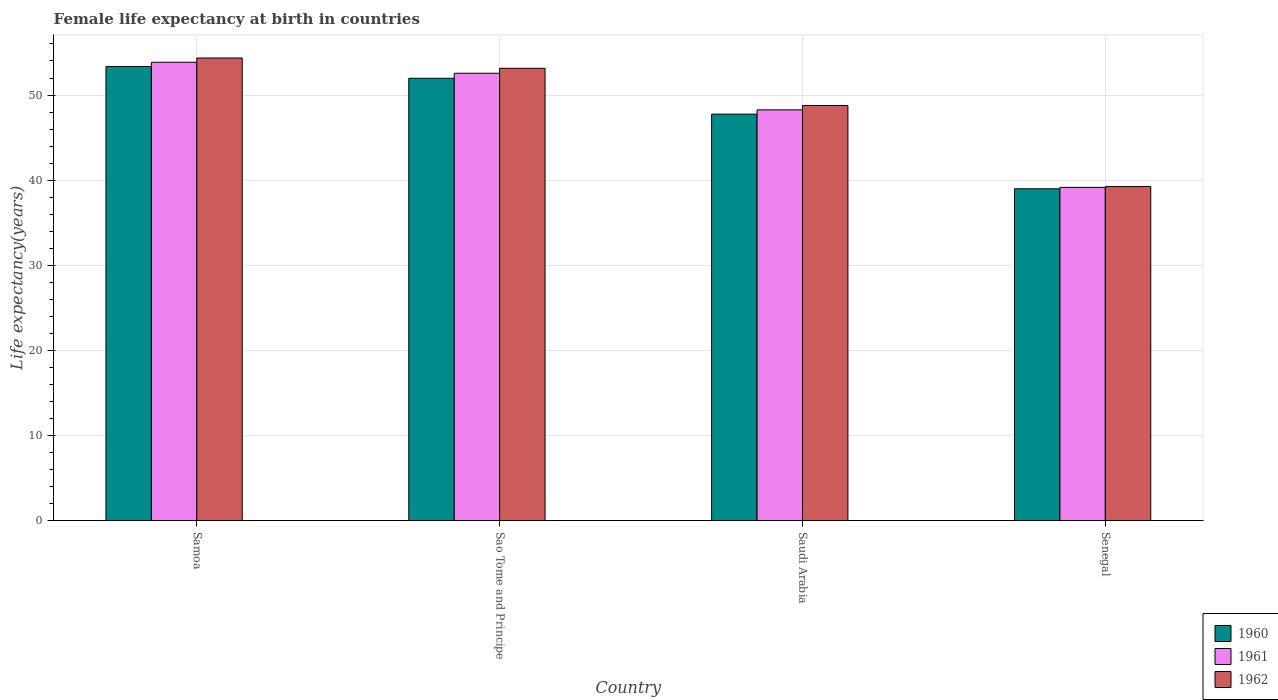How many different coloured bars are there?
Offer a very short reply. 3. How many bars are there on the 4th tick from the left?
Your answer should be compact. 3. What is the label of the 3rd group of bars from the left?
Your answer should be compact. Saudi Arabia. What is the female life expectancy at birth in 1962 in Saudi Arabia?
Your answer should be compact. 48.77. Across all countries, what is the maximum female life expectancy at birth in 1961?
Keep it short and to the point. 53.85. Across all countries, what is the minimum female life expectancy at birth in 1960?
Make the answer very short. 38.98. In which country was the female life expectancy at birth in 1961 maximum?
Offer a very short reply. Samoa. In which country was the female life expectancy at birth in 1961 minimum?
Your answer should be compact. Senegal. What is the total female life expectancy at birth in 1961 in the graph?
Your response must be concise. 193.82. What is the difference between the female life expectancy at birth in 1961 in Samoa and that in Senegal?
Your answer should be compact. 14.7. What is the difference between the female life expectancy at birth in 1960 in Sao Tome and Principe and the female life expectancy at birth in 1961 in Saudi Arabia?
Ensure brevity in your answer.  3.71. What is the average female life expectancy at birth in 1962 per country?
Offer a terse response. 48.88. What is the difference between the female life expectancy at birth of/in 1960 and female life expectancy at birth of/in 1961 in Saudi Arabia?
Ensure brevity in your answer.  -0.5. In how many countries, is the female life expectancy at birth in 1960 greater than 26 years?
Give a very brief answer. 4. What is the ratio of the female life expectancy at birth in 1961 in Samoa to that in Sao Tome and Principe?
Your answer should be very brief. 1.02. Is the female life expectancy at birth in 1961 in Sao Tome and Principe less than that in Saudi Arabia?
Your answer should be compact. No. What is the difference between the highest and the second highest female life expectancy at birth in 1961?
Provide a succinct answer. -4.3. What is the difference between the highest and the lowest female life expectancy at birth in 1960?
Your answer should be very brief. 14.37. In how many countries, is the female life expectancy at birth in 1961 greater than the average female life expectancy at birth in 1961 taken over all countries?
Give a very brief answer. 2. Is the sum of the female life expectancy at birth in 1962 in Sao Tome and Principe and Saudi Arabia greater than the maximum female life expectancy at birth in 1960 across all countries?
Your response must be concise. Yes. What does the 3rd bar from the left in Senegal represents?
Your response must be concise. 1962. How many bars are there?
Your answer should be very brief. 12. Are all the bars in the graph horizontal?
Provide a short and direct response. No. How many countries are there in the graph?
Your response must be concise. 4. What is the difference between two consecutive major ticks on the Y-axis?
Your answer should be compact. 10. Are the values on the major ticks of Y-axis written in scientific E-notation?
Your answer should be very brief. No. How are the legend labels stacked?
Your answer should be very brief. Vertical. What is the title of the graph?
Give a very brief answer. Female life expectancy at birth in countries. Does "2013" appear as one of the legend labels in the graph?
Your answer should be compact. No. What is the label or title of the Y-axis?
Provide a short and direct response. Life expectancy(years). What is the Life expectancy(years) of 1960 in Samoa?
Offer a terse response. 53.35. What is the Life expectancy(years) in 1961 in Samoa?
Your response must be concise. 53.85. What is the Life expectancy(years) in 1962 in Samoa?
Provide a short and direct response. 54.35. What is the Life expectancy(years) in 1960 in Sao Tome and Principe?
Give a very brief answer. 51.97. What is the Life expectancy(years) of 1961 in Sao Tome and Principe?
Make the answer very short. 52.56. What is the Life expectancy(years) in 1962 in Sao Tome and Principe?
Your answer should be compact. 53.14. What is the Life expectancy(years) of 1960 in Saudi Arabia?
Your response must be concise. 47.76. What is the Life expectancy(years) in 1961 in Saudi Arabia?
Your response must be concise. 48.26. What is the Life expectancy(years) in 1962 in Saudi Arabia?
Provide a succinct answer. 48.77. What is the Life expectancy(years) in 1960 in Senegal?
Your response must be concise. 38.98. What is the Life expectancy(years) in 1961 in Senegal?
Make the answer very short. 39.15. What is the Life expectancy(years) of 1962 in Senegal?
Offer a very short reply. 39.24. Across all countries, what is the maximum Life expectancy(years) of 1960?
Ensure brevity in your answer.  53.35. Across all countries, what is the maximum Life expectancy(years) in 1961?
Make the answer very short. 53.85. Across all countries, what is the maximum Life expectancy(years) in 1962?
Provide a short and direct response. 54.35. Across all countries, what is the minimum Life expectancy(years) in 1960?
Provide a succinct answer. 38.98. Across all countries, what is the minimum Life expectancy(years) of 1961?
Your answer should be compact. 39.15. Across all countries, what is the minimum Life expectancy(years) in 1962?
Provide a short and direct response. 39.24. What is the total Life expectancy(years) of 1960 in the graph?
Your response must be concise. 192.06. What is the total Life expectancy(years) of 1961 in the graph?
Your answer should be compact. 193.82. What is the total Life expectancy(years) in 1962 in the graph?
Provide a succinct answer. 195.51. What is the difference between the Life expectancy(years) of 1960 in Samoa and that in Sao Tome and Principe?
Your answer should be compact. 1.38. What is the difference between the Life expectancy(years) in 1961 in Samoa and that in Sao Tome and Principe?
Offer a very short reply. 1.29. What is the difference between the Life expectancy(years) of 1962 in Samoa and that in Sao Tome and Principe?
Make the answer very short. 1.21. What is the difference between the Life expectancy(years) in 1960 in Samoa and that in Saudi Arabia?
Your response must be concise. 5.59. What is the difference between the Life expectancy(years) in 1961 in Samoa and that in Saudi Arabia?
Your answer should be very brief. 5.59. What is the difference between the Life expectancy(years) in 1962 in Samoa and that in Saudi Arabia?
Your answer should be compact. 5.58. What is the difference between the Life expectancy(years) of 1960 in Samoa and that in Senegal?
Provide a short and direct response. 14.37. What is the difference between the Life expectancy(years) of 1961 in Samoa and that in Senegal?
Provide a short and direct response. 14.7. What is the difference between the Life expectancy(years) in 1962 in Samoa and that in Senegal?
Give a very brief answer. 15.11. What is the difference between the Life expectancy(years) of 1960 in Sao Tome and Principe and that in Saudi Arabia?
Your answer should be compact. 4.21. What is the difference between the Life expectancy(years) of 1961 in Sao Tome and Principe and that in Saudi Arabia?
Your answer should be very brief. 4.3. What is the difference between the Life expectancy(years) of 1962 in Sao Tome and Principe and that in Saudi Arabia?
Your response must be concise. 4.37. What is the difference between the Life expectancy(years) of 1960 in Sao Tome and Principe and that in Senegal?
Keep it short and to the point. 12.99. What is the difference between the Life expectancy(years) of 1961 in Sao Tome and Principe and that in Senegal?
Provide a short and direct response. 13.41. What is the difference between the Life expectancy(years) of 1962 in Sao Tome and Principe and that in Senegal?
Your answer should be compact. 13.89. What is the difference between the Life expectancy(years) of 1960 in Saudi Arabia and that in Senegal?
Offer a terse response. 8.77. What is the difference between the Life expectancy(years) in 1961 in Saudi Arabia and that in Senegal?
Your response must be concise. 9.11. What is the difference between the Life expectancy(years) of 1962 in Saudi Arabia and that in Senegal?
Make the answer very short. 9.53. What is the difference between the Life expectancy(years) of 1960 in Samoa and the Life expectancy(years) of 1961 in Sao Tome and Principe?
Keep it short and to the point. 0.79. What is the difference between the Life expectancy(years) of 1960 in Samoa and the Life expectancy(years) of 1962 in Sao Tome and Principe?
Keep it short and to the point. 0.21. What is the difference between the Life expectancy(years) in 1961 in Samoa and the Life expectancy(years) in 1962 in Sao Tome and Principe?
Ensure brevity in your answer.  0.71. What is the difference between the Life expectancy(years) in 1960 in Samoa and the Life expectancy(years) in 1961 in Saudi Arabia?
Your response must be concise. 5.09. What is the difference between the Life expectancy(years) of 1960 in Samoa and the Life expectancy(years) of 1962 in Saudi Arabia?
Make the answer very short. 4.58. What is the difference between the Life expectancy(years) in 1961 in Samoa and the Life expectancy(years) in 1962 in Saudi Arabia?
Keep it short and to the point. 5.08. What is the difference between the Life expectancy(years) in 1960 in Samoa and the Life expectancy(years) in 1961 in Senegal?
Give a very brief answer. 14.2. What is the difference between the Life expectancy(years) of 1960 in Samoa and the Life expectancy(years) of 1962 in Senegal?
Your response must be concise. 14.11. What is the difference between the Life expectancy(years) in 1961 in Samoa and the Life expectancy(years) in 1962 in Senegal?
Your answer should be compact. 14.61. What is the difference between the Life expectancy(years) in 1960 in Sao Tome and Principe and the Life expectancy(years) in 1961 in Saudi Arabia?
Keep it short and to the point. 3.71. What is the difference between the Life expectancy(years) of 1960 in Sao Tome and Principe and the Life expectancy(years) of 1962 in Saudi Arabia?
Your answer should be compact. 3.2. What is the difference between the Life expectancy(years) of 1961 in Sao Tome and Principe and the Life expectancy(years) of 1962 in Saudi Arabia?
Offer a very short reply. 3.79. What is the difference between the Life expectancy(years) of 1960 in Sao Tome and Principe and the Life expectancy(years) of 1961 in Senegal?
Your answer should be very brief. 12.82. What is the difference between the Life expectancy(years) in 1960 in Sao Tome and Principe and the Life expectancy(years) in 1962 in Senegal?
Offer a terse response. 12.72. What is the difference between the Life expectancy(years) of 1961 in Sao Tome and Principe and the Life expectancy(years) of 1962 in Senegal?
Offer a terse response. 13.32. What is the difference between the Life expectancy(years) of 1960 in Saudi Arabia and the Life expectancy(years) of 1961 in Senegal?
Your response must be concise. 8.6. What is the difference between the Life expectancy(years) in 1960 in Saudi Arabia and the Life expectancy(years) in 1962 in Senegal?
Make the answer very short. 8.51. What is the difference between the Life expectancy(years) of 1961 in Saudi Arabia and the Life expectancy(years) of 1962 in Senegal?
Provide a short and direct response. 9.01. What is the average Life expectancy(years) of 1960 per country?
Your answer should be very brief. 48.01. What is the average Life expectancy(years) of 1961 per country?
Provide a short and direct response. 48.45. What is the average Life expectancy(years) in 1962 per country?
Your answer should be very brief. 48.88. What is the difference between the Life expectancy(years) in 1960 and Life expectancy(years) in 1962 in Samoa?
Your answer should be very brief. -1. What is the difference between the Life expectancy(years) of 1960 and Life expectancy(years) of 1961 in Sao Tome and Principe?
Keep it short and to the point. -0.59. What is the difference between the Life expectancy(years) of 1960 and Life expectancy(years) of 1962 in Sao Tome and Principe?
Your answer should be compact. -1.17. What is the difference between the Life expectancy(years) of 1961 and Life expectancy(years) of 1962 in Sao Tome and Principe?
Your answer should be compact. -0.58. What is the difference between the Life expectancy(years) in 1960 and Life expectancy(years) in 1961 in Saudi Arabia?
Give a very brief answer. -0.5. What is the difference between the Life expectancy(years) in 1960 and Life expectancy(years) in 1962 in Saudi Arabia?
Keep it short and to the point. -1.02. What is the difference between the Life expectancy(years) in 1961 and Life expectancy(years) in 1962 in Saudi Arabia?
Ensure brevity in your answer.  -0.52. What is the difference between the Life expectancy(years) of 1960 and Life expectancy(years) of 1961 in Senegal?
Your answer should be very brief. -0.17. What is the difference between the Life expectancy(years) of 1960 and Life expectancy(years) of 1962 in Senegal?
Offer a very short reply. -0.26. What is the difference between the Life expectancy(years) of 1961 and Life expectancy(years) of 1962 in Senegal?
Offer a terse response. -0.09. What is the ratio of the Life expectancy(years) of 1960 in Samoa to that in Sao Tome and Principe?
Make the answer very short. 1.03. What is the ratio of the Life expectancy(years) in 1961 in Samoa to that in Sao Tome and Principe?
Provide a succinct answer. 1.02. What is the ratio of the Life expectancy(years) of 1962 in Samoa to that in Sao Tome and Principe?
Keep it short and to the point. 1.02. What is the ratio of the Life expectancy(years) in 1960 in Samoa to that in Saudi Arabia?
Your answer should be compact. 1.12. What is the ratio of the Life expectancy(years) in 1961 in Samoa to that in Saudi Arabia?
Make the answer very short. 1.12. What is the ratio of the Life expectancy(years) of 1962 in Samoa to that in Saudi Arabia?
Make the answer very short. 1.11. What is the ratio of the Life expectancy(years) of 1960 in Samoa to that in Senegal?
Offer a very short reply. 1.37. What is the ratio of the Life expectancy(years) in 1961 in Samoa to that in Senegal?
Keep it short and to the point. 1.38. What is the ratio of the Life expectancy(years) in 1962 in Samoa to that in Senegal?
Keep it short and to the point. 1.38. What is the ratio of the Life expectancy(years) in 1960 in Sao Tome and Principe to that in Saudi Arabia?
Your answer should be compact. 1.09. What is the ratio of the Life expectancy(years) of 1961 in Sao Tome and Principe to that in Saudi Arabia?
Your answer should be very brief. 1.09. What is the ratio of the Life expectancy(years) in 1962 in Sao Tome and Principe to that in Saudi Arabia?
Keep it short and to the point. 1.09. What is the ratio of the Life expectancy(years) in 1960 in Sao Tome and Principe to that in Senegal?
Offer a terse response. 1.33. What is the ratio of the Life expectancy(years) in 1961 in Sao Tome and Principe to that in Senegal?
Provide a succinct answer. 1.34. What is the ratio of the Life expectancy(years) in 1962 in Sao Tome and Principe to that in Senegal?
Provide a short and direct response. 1.35. What is the ratio of the Life expectancy(years) of 1960 in Saudi Arabia to that in Senegal?
Provide a succinct answer. 1.23. What is the ratio of the Life expectancy(years) in 1961 in Saudi Arabia to that in Senegal?
Your answer should be very brief. 1.23. What is the ratio of the Life expectancy(years) of 1962 in Saudi Arabia to that in Senegal?
Your response must be concise. 1.24. What is the difference between the highest and the second highest Life expectancy(years) of 1960?
Keep it short and to the point. 1.38. What is the difference between the highest and the second highest Life expectancy(years) of 1961?
Your answer should be very brief. 1.29. What is the difference between the highest and the second highest Life expectancy(years) of 1962?
Offer a very short reply. 1.21. What is the difference between the highest and the lowest Life expectancy(years) of 1960?
Provide a succinct answer. 14.37. What is the difference between the highest and the lowest Life expectancy(years) of 1961?
Offer a terse response. 14.7. What is the difference between the highest and the lowest Life expectancy(years) in 1962?
Make the answer very short. 15.11. 